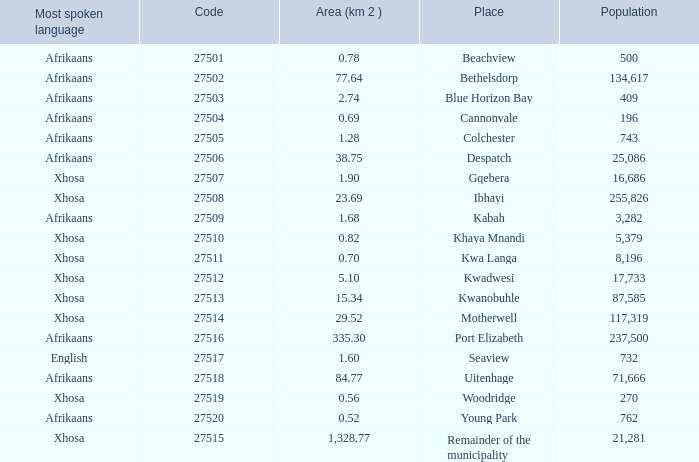What is the lowest code number for the remainder of the municipality that has an area bigger than 15.34 squared kilometers, a population greater than 762 and a language of xhosa spoken? 27515.0. 